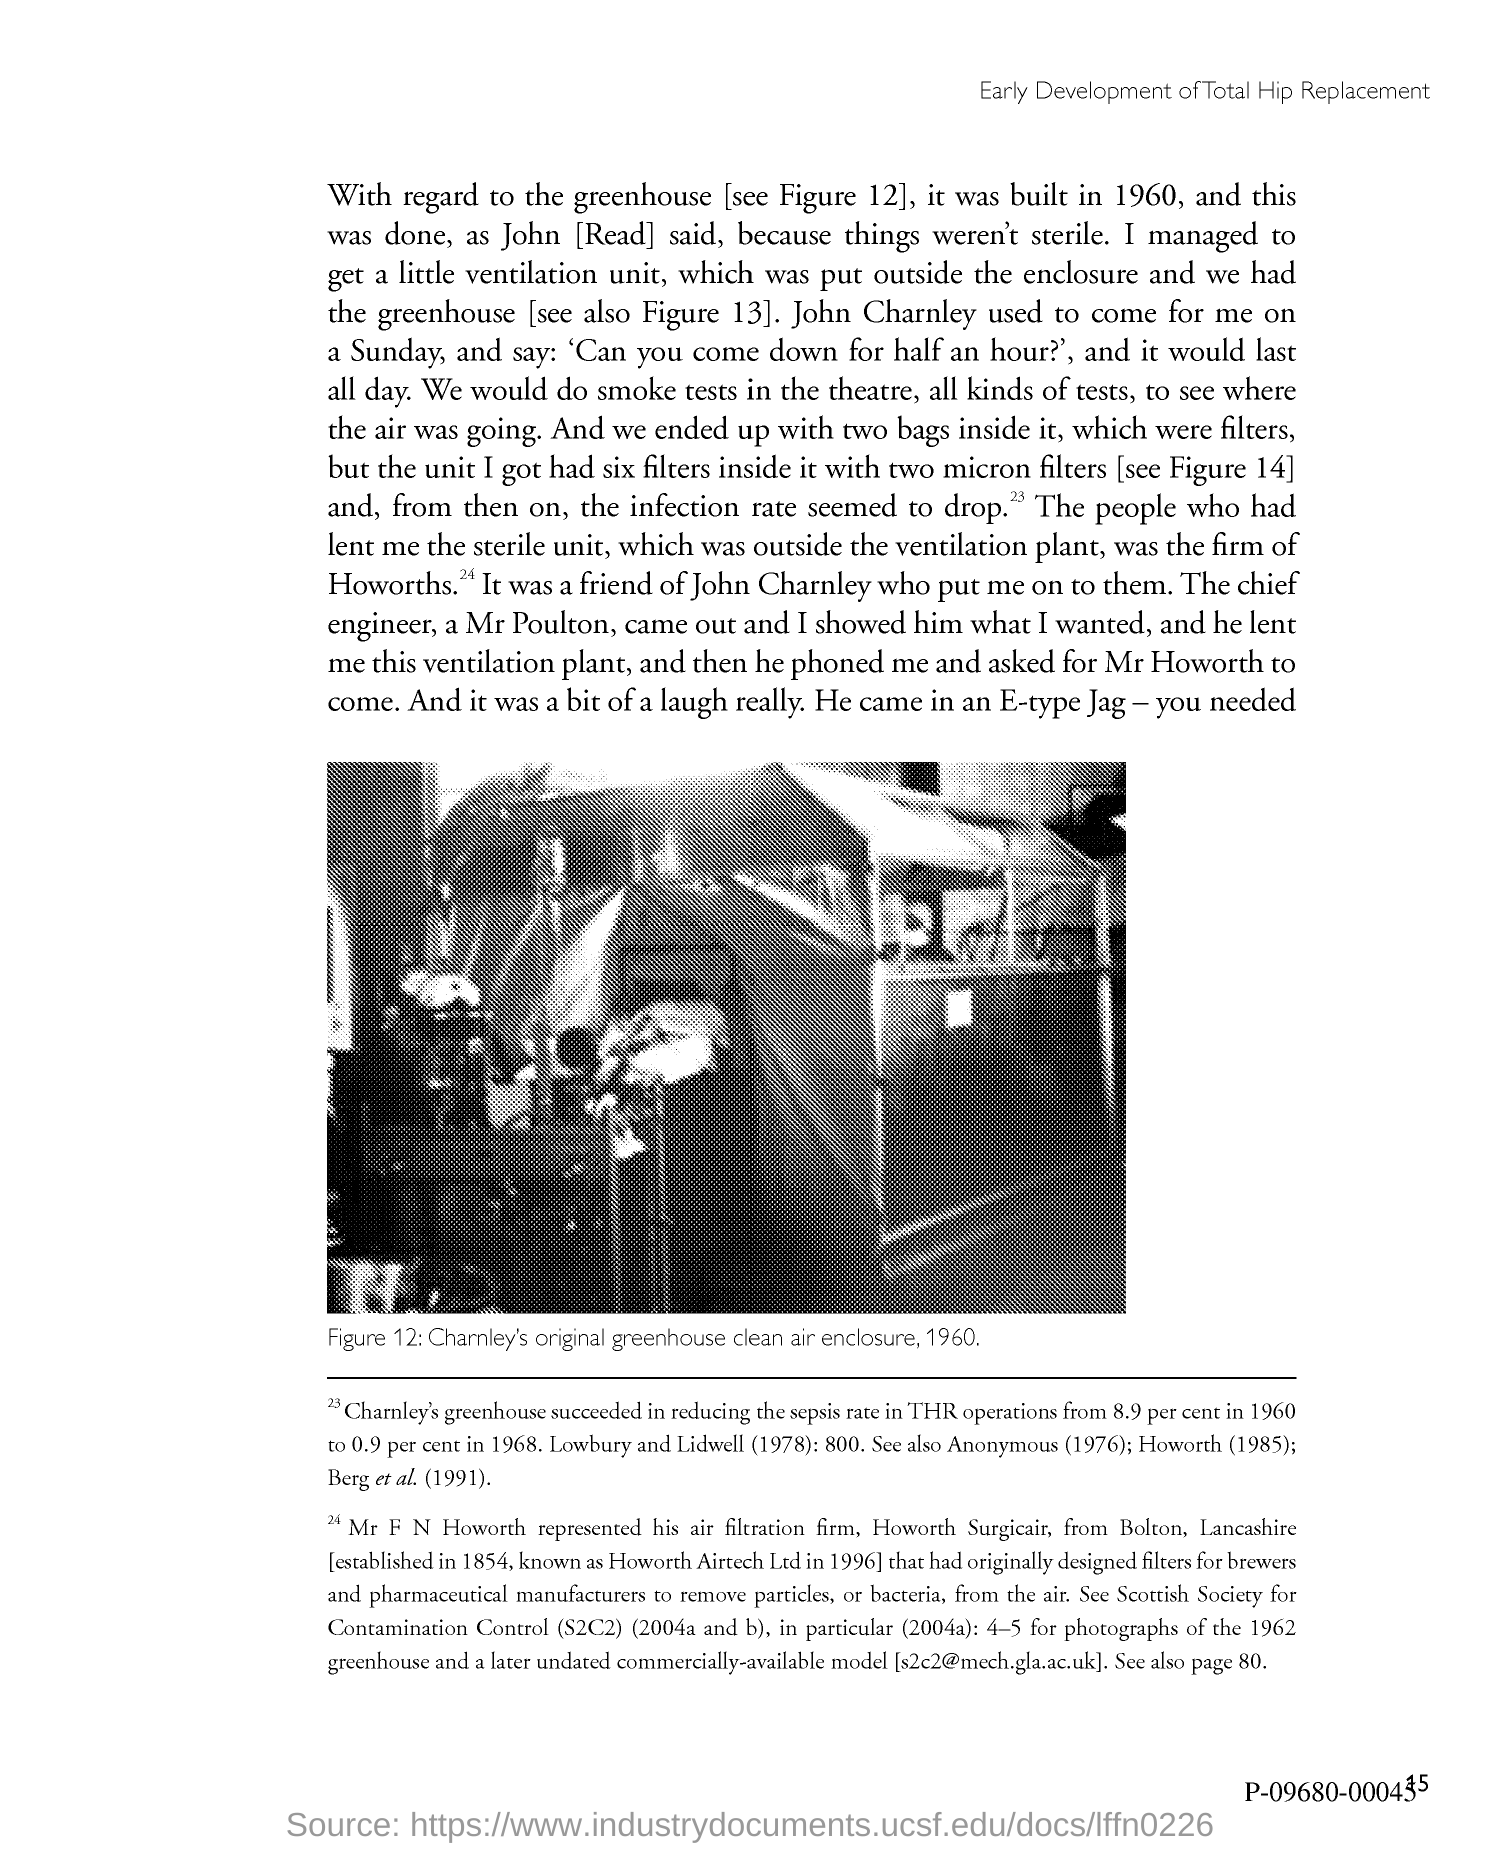Point out several critical features in this image. Figure 12 in this document depicts Charnley's original greenhouse clean air enclosure from 1960. 